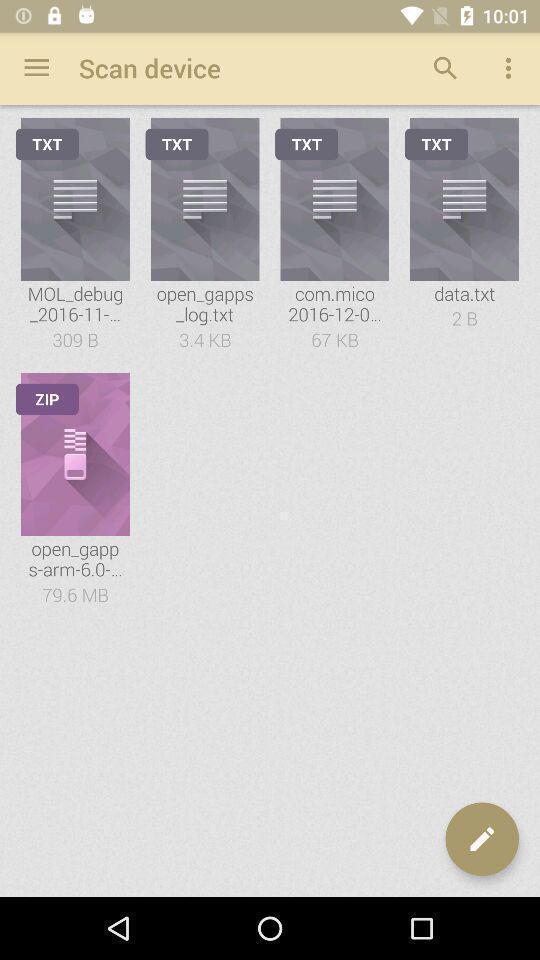Please provide a description for this image. Screen showing various zip files. 